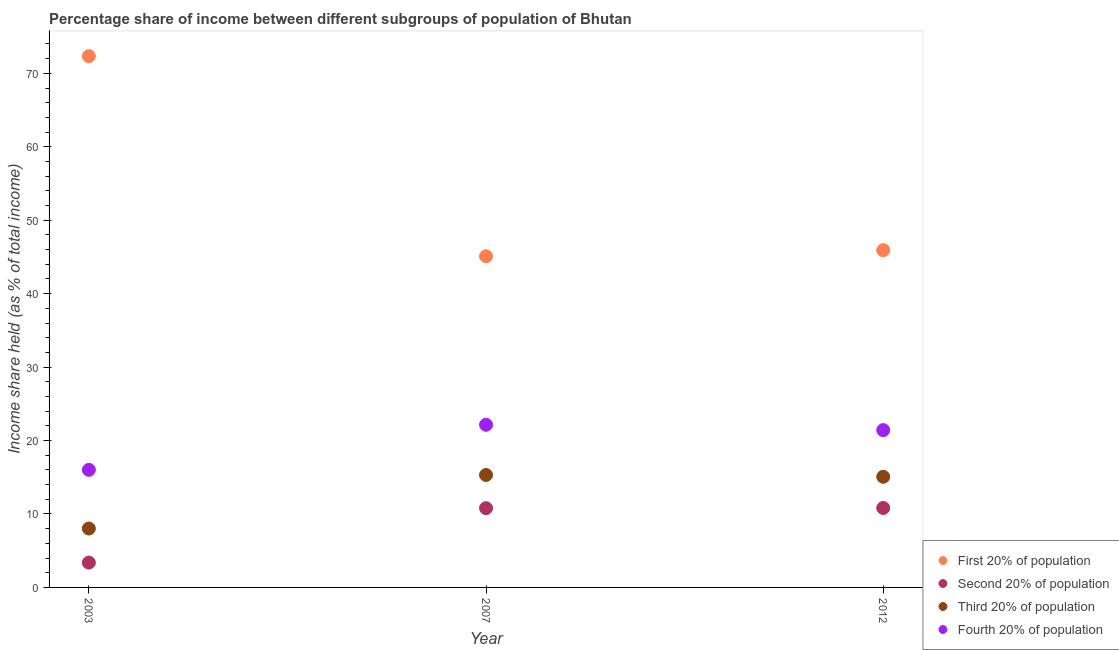How many different coloured dotlines are there?
Offer a terse response. 4. What is the share of the income held by second 20% of the population in 2007?
Offer a very short reply. 10.79. Across all years, what is the maximum share of the income held by fourth 20% of the population?
Offer a very short reply. 22.15. Across all years, what is the minimum share of the income held by second 20% of the population?
Offer a very short reply. 3.38. In which year was the share of the income held by second 20% of the population maximum?
Offer a terse response. 2012. What is the total share of the income held by second 20% of the population in the graph?
Keep it short and to the point. 24.99. What is the difference between the share of the income held by fourth 20% of the population in 2003 and that in 2012?
Provide a succinct answer. -5.41. What is the difference between the share of the income held by third 20% of the population in 2007 and the share of the income held by first 20% of the population in 2012?
Provide a short and direct response. -30.61. What is the average share of the income held by third 20% of the population per year?
Offer a terse response. 12.8. In the year 2003, what is the difference between the share of the income held by third 20% of the population and share of the income held by first 20% of the population?
Your answer should be very brief. -64.32. In how many years, is the share of the income held by third 20% of the population greater than 64 %?
Your response must be concise. 0. What is the ratio of the share of the income held by third 20% of the population in 2007 to that in 2012?
Ensure brevity in your answer.  1.02. Is the share of the income held by fourth 20% of the population in 2003 less than that in 2012?
Offer a very short reply. Yes. Is the difference between the share of the income held by fourth 20% of the population in 2007 and 2012 greater than the difference between the share of the income held by second 20% of the population in 2007 and 2012?
Your answer should be compact. Yes. What is the difference between the highest and the second highest share of the income held by third 20% of the population?
Ensure brevity in your answer.  0.24. What is the difference between the highest and the lowest share of the income held by fourth 20% of the population?
Your response must be concise. 6.14. Is the sum of the share of the income held by second 20% of the population in 2003 and 2007 greater than the maximum share of the income held by first 20% of the population across all years?
Provide a succinct answer. No. Is the share of the income held by third 20% of the population strictly less than the share of the income held by fourth 20% of the population over the years?
Offer a terse response. Yes. How many dotlines are there?
Keep it short and to the point. 4. How many years are there in the graph?
Keep it short and to the point. 3. Where does the legend appear in the graph?
Offer a very short reply. Bottom right. How are the legend labels stacked?
Make the answer very short. Vertical. What is the title of the graph?
Ensure brevity in your answer.  Percentage share of income between different subgroups of population of Bhutan. What is the label or title of the X-axis?
Offer a very short reply. Year. What is the label or title of the Y-axis?
Make the answer very short. Income share held (as % of total income). What is the Income share held (as % of total income) of First 20% of population in 2003?
Provide a succinct answer. 72.34. What is the Income share held (as % of total income) in Second 20% of population in 2003?
Your response must be concise. 3.38. What is the Income share held (as % of total income) of Third 20% of population in 2003?
Your answer should be very brief. 8.02. What is the Income share held (as % of total income) in Fourth 20% of population in 2003?
Provide a short and direct response. 16.01. What is the Income share held (as % of total income) in First 20% of population in 2007?
Ensure brevity in your answer.  45.1. What is the Income share held (as % of total income) of Second 20% of population in 2007?
Offer a terse response. 10.79. What is the Income share held (as % of total income) of Third 20% of population in 2007?
Your answer should be very brief. 15.31. What is the Income share held (as % of total income) in Fourth 20% of population in 2007?
Provide a short and direct response. 22.15. What is the Income share held (as % of total income) of First 20% of population in 2012?
Keep it short and to the point. 45.92. What is the Income share held (as % of total income) of Second 20% of population in 2012?
Keep it short and to the point. 10.82. What is the Income share held (as % of total income) in Third 20% of population in 2012?
Make the answer very short. 15.07. What is the Income share held (as % of total income) in Fourth 20% of population in 2012?
Your answer should be compact. 21.42. Across all years, what is the maximum Income share held (as % of total income) of First 20% of population?
Your answer should be very brief. 72.34. Across all years, what is the maximum Income share held (as % of total income) in Second 20% of population?
Your answer should be very brief. 10.82. Across all years, what is the maximum Income share held (as % of total income) of Third 20% of population?
Ensure brevity in your answer.  15.31. Across all years, what is the maximum Income share held (as % of total income) in Fourth 20% of population?
Offer a very short reply. 22.15. Across all years, what is the minimum Income share held (as % of total income) of First 20% of population?
Offer a terse response. 45.1. Across all years, what is the minimum Income share held (as % of total income) of Second 20% of population?
Ensure brevity in your answer.  3.38. Across all years, what is the minimum Income share held (as % of total income) in Third 20% of population?
Your answer should be compact. 8.02. Across all years, what is the minimum Income share held (as % of total income) of Fourth 20% of population?
Make the answer very short. 16.01. What is the total Income share held (as % of total income) of First 20% of population in the graph?
Offer a terse response. 163.36. What is the total Income share held (as % of total income) in Second 20% of population in the graph?
Keep it short and to the point. 24.99. What is the total Income share held (as % of total income) in Third 20% of population in the graph?
Ensure brevity in your answer.  38.4. What is the total Income share held (as % of total income) in Fourth 20% of population in the graph?
Keep it short and to the point. 59.58. What is the difference between the Income share held (as % of total income) of First 20% of population in 2003 and that in 2007?
Offer a very short reply. 27.24. What is the difference between the Income share held (as % of total income) of Second 20% of population in 2003 and that in 2007?
Your answer should be very brief. -7.41. What is the difference between the Income share held (as % of total income) in Third 20% of population in 2003 and that in 2007?
Your answer should be very brief. -7.29. What is the difference between the Income share held (as % of total income) of Fourth 20% of population in 2003 and that in 2007?
Your answer should be compact. -6.14. What is the difference between the Income share held (as % of total income) of First 20% of population in 2003 and that in 2012?
Provide a succinct answer. 26.42. What is the difference between the Income share held (as % of total income) of Second 20% of population in 2003 and that in 2012?
Your answer should be very brief. -7.44. What is the difference between the Income share held (as % of total income) of Third 20% of population in 2003 and that in 2012?
Provide a succinct answer. -7.05. What is the difference between the Income share held (as % of total income) in Fourth 20% of population in 2003 and that in 2012?
Make the answer very short. -5.41. What is the difference between the Income share held (as % of total income) of First 20% of population in 2007 and that in 2012?
Your response must be concise. -0.82. What is the difference between the Income share held (as % of total income) in Second 20% of population in 2007 and that in 2012?
Offer a terse response. -0.03. What is the difference between the Income share held (as % of total income) of Third 20% of population in 2007 and that in 2012?
Ensure brevity in your answer.  0.24. What is the difference between the Income share held (as % of total income) in Fourth 20% of population in 2007 and that in 2012?
Your answer should be compact. 0.73. What is the difference between the Income share held (as % of total income) of First 20% of population in 2003 and the Income share held (as % of total income) of Second 20% of population in 2007?
Give a very brief answer. 61.55. What is the difference between the Income share held (as % of total income) in First 20% of population in 2003 and the Income share held (as % of total income) in Third 20% of population in 2007?
Provide a succinct answer. 57.03. What is the difference between the Income share held (as % of total income) in First 20% of population in 2003 and the Income share held (as % of total income) in Fourth 20% of population in 2007?
Your response must be concise. 50.19. What is the difference between the Income share held (as % of total income) in Second 20% of population in 2003 and the Income share held (as % of total income) in Third 20% of population in 2007?
Offer a terse response. -11.93. What is the difference between the Income share held (as % of total income) of Second 20% of population in 2003 and the Income share held (as % of total income) of Fourth 20% of population in 2007?
Your answer should be very brief. -18.77. What is the difference between the Income share held (as % of total income) of Third 20% of population in 2003 and the Income share held (as % of total income) of Fourth 20% of population in 2007?
Your response must be concise. -14.13. What is the difference between the Income share held (as % of total income) of First 20% of population in 2003 and the Income share held (as % of total income) of Second 20% of population in 2012?
Your answer should be compact. 61.52. What is the difference between the Income share held (as % of total income) in First 20% of population in 2003 and the Income share held (as % of total income) in Third 20% of population in 2012?
Make the answer very short. 57.27. What is the difference between the Income share held (as % of total income) in First 20% of population in 2003 and the Income share held (as % of total income) in Fourth 20% of population in 2012?
Your response must be concise. 50.92. What is the difference between the Income share held (as % of total income) in Second 20% of population in 2003 and the Income share held (as % of total income) in Third 20% of population in 2012?
Provide a succinct answer. -11.69. What is the difference between the Income share held (as % of total income) of Second 20% of population in 2003 and the Income share held (as % of total income) of Fourth 20% of population in 2012?
Your response must be concise. -18.04. What is the difference between the Income share held (as % of total income) in First 20% of population in 2007 and the Income share held (as % of total income) in Second 20% of population in 2012?
Provide a short and direct response. 34.28. What is the difference between the Income share held (as % of total income) of First 20% of population in 2007 and the Income share held (as % of total income) of Third 20% of population in 2012?
Give a very brief answer. 30.03. What is the difference between the Income share held (as % of total income) in First 20% of population in 2007 and the Income share held (as % of total income) in Fourth 20% of population in 2012?
Your answer should be very brief. 23.68. What is the difference between the Income share held (as % of total income) of Second 20% of population in 2007 and the Income share held (as % of total income) of Third 20% of population in 2012?
Offer a very short reply. -4.28. What is the difference between the Income share held (as % of total income) of Second 20% of population in 2007 and the Income share held (as % of total income) of Fourth 20% of population in 2012?
Make the answer very short. -10.63. What is the difference between the Income share held (as % of total income) in Third 20% of population in 2007 and the Income share held (as % of total income) in Fourth 20% of population in 2012?
Provide a succinct answer. -6.11. What is the average Income share held (as % of total income) of First 20% of population per year?
Give a very brief answer. 54.45. What is the average Income share held (as % of total income) in Second 20% of population per year?
Provide a short and direct response. 8.33. What is the average Income share held (as % of total income) in Third 20% of population per year?
Your answer should be compact. 12.8. What is the average Income share held (as % of total income) of Fourth 20% of population per year?
Your response must be concise. 19.86. In the year 2003, what is the difference between the Income share held (as % of total income) in First 20% of population and Income share held (as % of total income) in Second 20% of population?
Your answer should be very brief. 68.96. In the year 2003, what is the difference between the Income share held (as % of total income) in First 20% of population and Income share held (as % of total income) in Third 20% of population?
Offer a terse response. 64.32. In the year 2003, what is the difference between the Income share held (as % of total income) of First 20% of population and Income share held (as % of total income) of Fourth 20% of population?
Make the answer very short. 56.33. In the year 2003, what is the difference between the Income share held (as % of total income) in Second 20% of population and Income share held (as % of total income) in Third 20% of population?
Offer a terse response. -4.64. In the year 2003, what is the difference between the Income share held (as % of total income) of Second 20% of population and Income share held (as % of total income) of Fourth 20% of population?
Ensure brevity in your answer.  -12.63. In the year 2003, what is the difference between the Income share held (as % of total income) of Third 20% of population and Income share held (as % of total income) of Fourth 20% of population?
Provide a succinct answer. -7.99. In the year 2007, what is the difference between the Income share held (as % of total income) in First 20% of population and Income share held (as % of total income) in Second 20% of population?
Your response must be concise. 34.31. In the year 2007, what is the difference between the Income share held (as % of total income) of First 20% of population and Income share held (as % of total income) of Third 20% of population?
Make the answer very short. 29.79. In the year 2007, what is the difference between the Income share held (as % of total income) of First 20% of population and Income share held (as % of total income) of Fourth 20% of population?
Give a very brief answer. 22.95. In the year 2007, what is the difference between the Income share held (as % of total income) in Second 20% of population and Income share held (as % of total income) in Third 20% of population?
Your answer should be compact. -4.52. In the year 2007, what is the difference between the Income share held (as % of total income) in Second 20% of population and Income share held (as % of total income) in Fourth 20% of population?
Provide a short and direct response. -11.36. In the year 2007, what is the difference between the Income share held (as % of total income) in Third 20% of population and Income share held (as % of total income) in Fourth 20% of population?
Offer a very short reply. -6.84. In the year 2012, what is the difference between the Income share held (as % of total income) of First 20% of population and Income share held (as % of total income) of Second 20% of population?
Ensure brevity in your answer.  35.1. In the year 2012, what is the difference between the Income share held (as % of total income) of First 20% of population and Income share held (as % of total income) of Third 20% of population?
Provide a short and direct response. 30.85. In the year 2012, what is the difference between the Income share held (as % of total income) in First 20% of population and Income share held (as % of total income) in Fourth 20% of population?
Provide a short and direct response. 24.5. In the year 2012, what is the difference between the Income share held (as % of total income) in Second 20% of population and Income share held (as % of total income) in Third 20% of population?
Your response must be concise. -4.25. In the year 2012, what is the difference between the Income share held (as % of total income) in Second 20% of population and Income share held (as % of total income) in Fourth 20% of population?
Your answer should be very brief. -10.6. In the year 2012, what is the difference between the Income share held (as % of total income) in Third 20% of population and Income share held (as % of total income) in Fourth 20% of population?
Provide a succinct answer. -6.35. What is the ratio of the Income share held (as % of total income) of First 20% of population in 2003 to that in 2007?
Offer a terse response. 1.6. What is the ratio of the Income share held (as % of total income) of Second 20% of population in 2003 to that in 2007?
Your response must be concise. 0.31. What is the ratio of the Income share held (as % of total income) of Third 20% of population in 2003 to that in 2007?
Your answer should be compact. 0.52. What is the ratio of the Income share held (as % of total income) in Fourth 20% of population in 2003 to that in 2007?
Your answer should be very brief. 0.72. What is the ratio of the Income share held (as % of total income) in First 20% of population in 2003 to that in 2012?
Your response must be concise. 1.58. What is the ratio of the Income share held (as % of total income) in Second 20% of population in 2003 to that in 2012?
Offer a very short reply. 0.31. What is the ratio of the Income share held (as % of total income) in Third 20% of population in 2003 to that in 2012?
Give a very brief answer. 0.53. What is the ratio of the Income share held (as % of total income) in Fourth 20% of population in 2003 to that in 2012?
Keep it short and to the point. 0.75. What is the ratio of the Income share held (as % of total income) in First 20% of population in 2007 to that in 2012?
Ensure brevity in your answer.  0.98. What is the ratio of the Income share held (as % of total income) of Third 20% of population in 2007 to that in 2012?
Give a very brief answer. 1.02. What is the ratio of the Income share held (as % of total income) in Fourth 20% of population in 2007 to that in 2012?
Keep it short and to the point. 1.03. What is the difference between the highest and the second highest Income share held (as % of total income) in First 20% of population?
Give a very brief answer. 26.42. What is the difference between the highest and the second highest Income share held (as % of total income) in Second 20% of population?
Keep it short and to the point. 0.03. What is the difference between the highest and the second highest Income share held (as % of total income) in Third 20% of population?
Ensure brevity in your answer.  0.24. What is the difference between the highest and the second highest Income share held (as % of total income) of Fourth 20% of population?
Keep it short and to the point. 0.73. What is the difference between the highest and the lowest Income share held (as % of total income) of First 20% of population?
Keep it short and to the point. 27.24. What is the difference between the highest and the lowest Income share held (as % of total income) in Second 20% of population?
Your answer should be very brief. 7.44. What is the difference between the highest and the lowest Income share held (as % of total income) of Third 20% of population?
Provide a succinct answer. 7.29. What is the difference between the highest and the lowest Income share held (as % of total income) of Fourth 20% of population?
Ensure brevity in your answer.  6.14. 